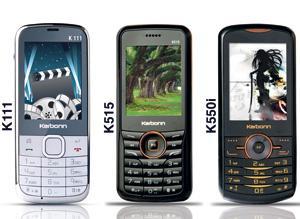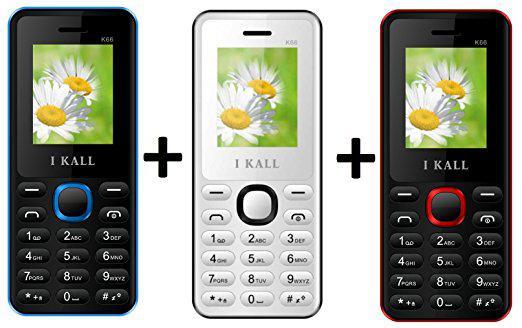The first image is the image on the left, the second image is the image on the right. Considering the images on both sides, is "Each image contains exactly three phones, which are displayed vertically facing screen-first and do not have a flip-open top." valid? Answer yes or no. Yes. The first image is the image on the left, the second image is the image on the right. For the images displayed, is the sentence "The left and right image contains the same number of vertical phones." factually correct? Answer yes or no. Yes. 